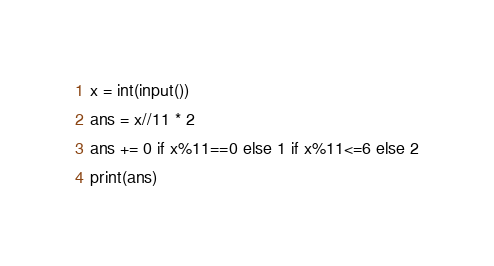<code> <loc_0><loc_0><loc_500><loc_500><_Python_>x = int(input())
ans = x//11 * 2
ans += 0 if x%11==0 else 1 if x%11<=6 else 2
print(ans)</code> 